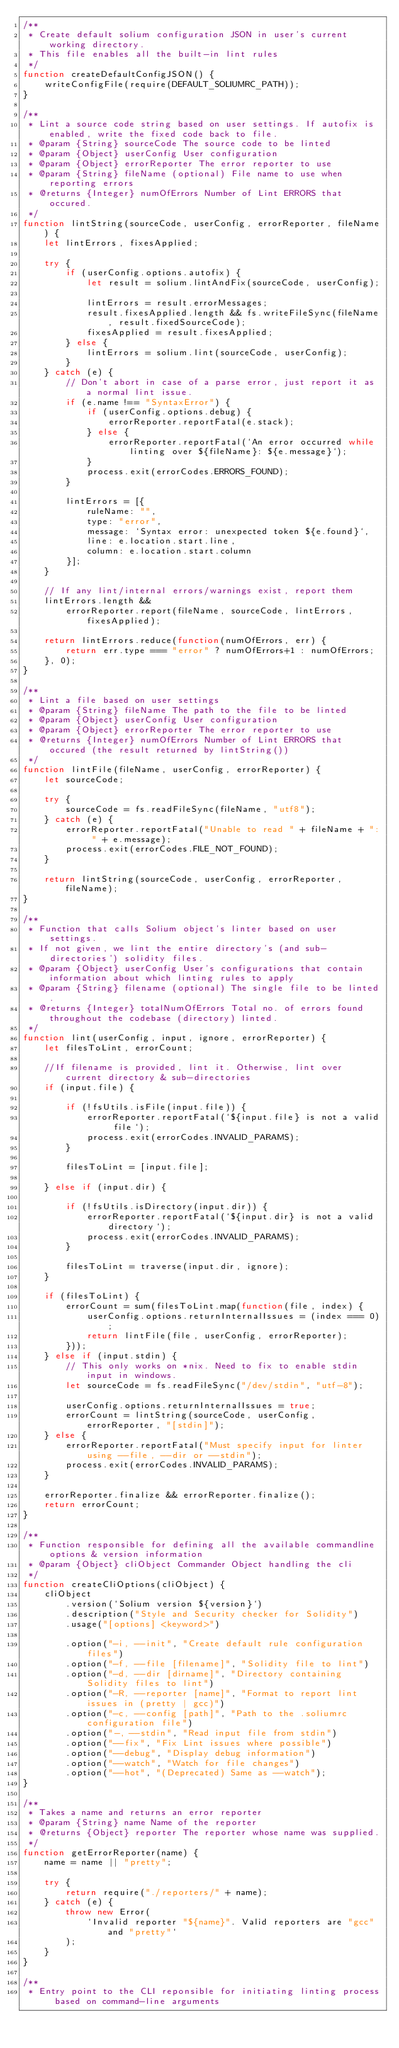Convert code to text. <code><loc_0><loc_0><loc_500><loc_500><_JavaScript_>/**
 * Create default solium configuration JSON in user's current working directory.
 * This file enables all the built-in lint rules
 */
function createDefaultConfigJSON() {
    writeConfigFile(require(DEFAULT_SOLIUMRC_PATH));
}

/**
 * Lint a source code string based on user settings. If autofix is enabled, write the fixed code back to file.
 * @param {String} sourceCode The source code to be linted
 * @param {Object} userConfig User configuration
 * @param {Object} errorReporter The error reporter to use
 * @param {String} fileName (optional) File name to use when reporting errors
 * @returns {Integer} numOfErrors Number of Lint ERRORS that occured.
 */
function lintString(sourceCode, userConfig, errorReporter, fileName) {
    let lintErrors, fixesApplied;

    try {
        if (userConfig.options.autofix) {
            let result = solium.lintAndFix(sourceCode, userConfig);

            lintErrors = result.errorMessages;
            result.fixesApplied.length && fs.writeFileSync(fileName, result.fixedSourceCode);
            fixesApplied = result.fixesApplied;
        } else {
            lintErrors = solium.lint(sourceCode, userConfig);
        }
    } catch (e) {
        // Don't abort in case of a parse error, just report it as a normal lint issue.
        if (e.name !== "SyntaxError") {
            if (userConfig.options.debug) {
                errorReporter.reportFatal(e.stack);
            } else {
                errorReporter.reportFatal(`An error occurred while linting over ${fileName}: ${e.message}`);
            }
            process.exit(errorCodes.ERRORS_FOUND);
        }

        lintErrors = [{
            ruleName: "",
            type: "error",
            message: `Syntax error: unexpected token ${e.found}`,
            line: e.location.start.line,
            column: e.location.start.column
        }];
    }

    // If any lint/internal errors/warnings exist, report them
    lintErrors.length &&
        errorReporter.report(fileName, sourceCode, lintErrors, fixesApplied);

    return lintErrors.reduce(function(numOfErrors, err) {
        return err.type === "error" ? numOfErrors+1 : numOfErrors;
    }, 0);
}

/**
 * Lint a file based on user settings
 * @param {String} fileName The path to the file to be linted
 * @param {Object} userConfig User configuration
 * @param {Object} errorReporter The error reporter to use
 * @returns {Integer} numOfErrors Number of Lint ERRORS that occured (the result returned by lintString())
 */
function lintFile(fileName, userConfig, errorReporter) {
    let sourceCode;

    try {
        sourceCode = fs.readFileSync(fileName, "utf8");
    } catch (e) {
        errorReporter.reportFatal("Unable to read " + fileName + ": " + e.message);
        process.exit(errorCodes.FILE_NOT_FOUND);
    }

    return lintString(sourceCode, userConfig, errorReporter, fileName);
}

/**
 * Function that calls Solium object's linter based on user settings.
 * If not given, we lint the entire directory's (and sub-directories') solidity files.
 * @param {Object} userConfig User's configurations that contain information about which linting rules to apply
 * @param {String} filename (optional) The single file to be linted.
 * @returns {Integer} totalNumOfErrors Total no. of errors found throughout the codebase (directory) linted.
 */
function lint(userConfig, input, ignore, errorReporter) {
    let filesToLint, errorCount;

    //If filename is provided, lint it. Otherwise, lint over current directory & sub-directories
    if (input.file) {

        if (!fsUtils.isFile(input.file)) {
            errorReporter.reportFatal(`${input.file} is not a valid file`);
            process.exit(errorCodes.INVALID_PARAMS);
        }

        filesToLint = [input.file];

    } else if (input.dir) {

        if (!fsUtils.isDirectory(input.dir)) {
            errorReporter.reportFatal(`${input.dir} is not a valid directory`);
            process.exit(errorCodes.INVALID_PARAMS);
        }

        filesToLint = traverse(input.dir, ignore);
    }

    if (filesToLint) {
        errorCount = sum(filesToLint.map(function(file, index) {
            userConfig.options.returnInternalIssues = (index === 0);
            return lintFile(file, userConfig, errorReporter);
        }));
    } else if (input.stdin) {
        // This only works on *nix. Need to fix to enable stdin input in windows.
        let sourceCode = fs.readFileSync("/dev/stdin", "utf-8");

        userConfig.options.returnInternalIssues = true;
        errorCount = lintString(sourceCode, userConfig, errorReporter, "[stdin]");
    } else {
        errorReporter.reportFatal("Must specify input for linter using --file, --dir or --stdin");
        process.exit(errorCodes.INVALID_PARAMS);
    }

    errorReporter.finalize && errorReporter.finalize();
    return errorCount;
}

/**
 * Function responsible for defining all the available commandline options & version information
 * @param {Object} cliObject Commander Object handling the cli
 */
function createCliOptions(cliObject) {
    cliObject
        .version(`Solium version ${version}`)
        .description("Style and Security checker for Solidity")
        .usage("[options] <keyword>")

        .option("-i, --init", "Create default rule configuration files")
        .option("-f, --file [filename]", "Solidity file to lint")
        .option("-d, --dir [dirname]", "Directory containing Solidity files to lint")
        .option("-R, --reporter [name]", "Format to report lint issues in (pretty | gcc)")
        .option("-c, --config [path]", "Path to the .soliumrc configuration file")
        .option("-, --stdin", "Read input file from stdin")
        .option("--fix", "Fix Lint issues where possible")
        .option("--debug", "Display debug information")
        .option("--watch", "Watch for file changes")
        .option("--hot", "(Deprecated) Same as --watch");
}

/**
 * Takes a name and returns an error reporter
 * @param {String} name Name of the reporter
 * @returns {Object} reporter The reporter whose name was supplied.
 */
function getErrorReporter(name) {
    name = name || "pretty";

    try {
        return require("./reporters/" + name);
    } catch (e) {
        throw new Error(
            `Invalid reporter "${name}". Valid reporters are "gcc" and "pretty"`
        );
    }
}

/**
 * Entry point to the CLI reponsible for initiating linting process based on command-line arguments</code> 